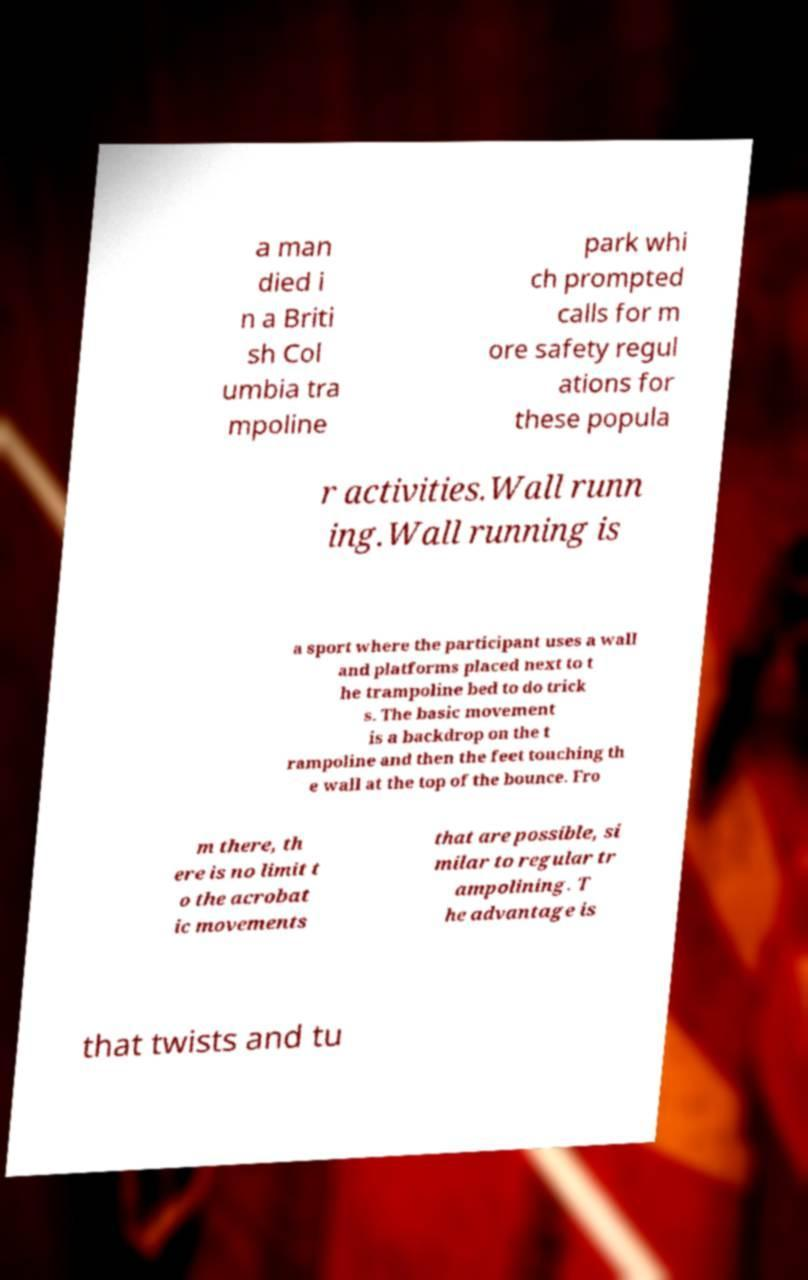For documentation purposes, I need the text within this image transcribed. Could you provide that? a man died i n a Briti sh Col umbia tra mpoline park whi ch prompted calls for m ore safety regul ations for these popula r activities.Wall runn ing.Wall running is a sport where the participant uses a wall and platforms placed next to t he trampoline bed to do trick s. The basic movement is a backdrop on the t rampoline and then the feet touching th e wall at the top of the bounce. Fro m there, th ere is no limit t o the acrobat ic movements that are possible, si milar to regular tr ampolining. T he advantage is that twists and tu 